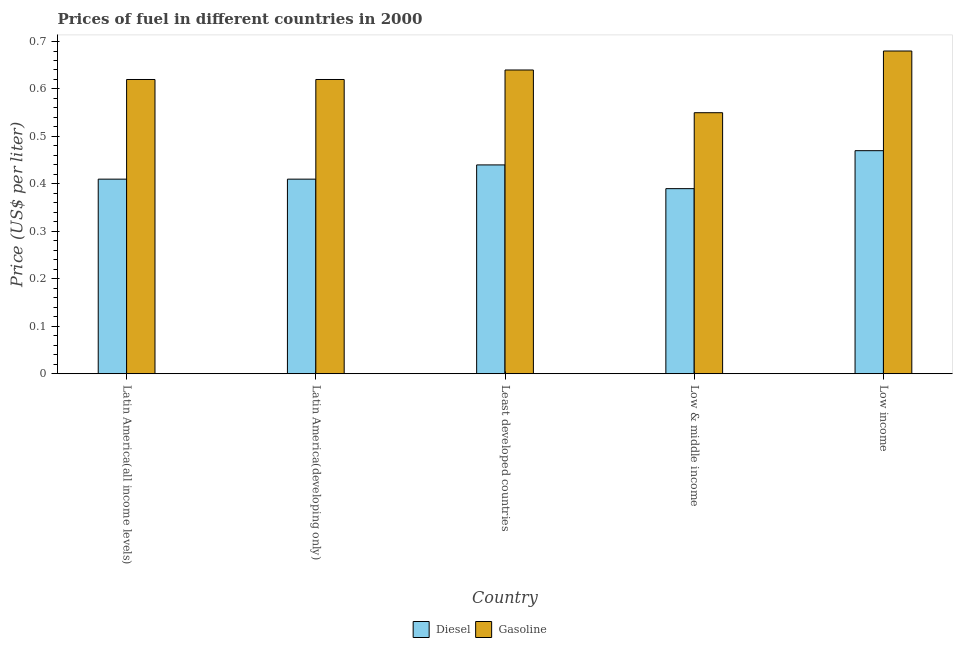How many groups of bars are there?
Your answer should be compact. 5. Are the number of bars per tick equal to the number of legend labels?
Your answer should be compact. Yes. How many bars are there on the 5th tick from the right?
Your answer should be very brief. 2. What is the label of the 3rd group of bars from the left?
Offer a terse response. Least developed countries. What is the gasoline price in Low & middle income?
Make the answer very short. 0.55. Across all countries, what is the maximum diesel price?
Make the answer very short. 0.47. Across all countries, what is the minimum gasoline price?
Give a very brief answer. 0.55. What is the total diesel price in the graph?
Your answer should be compact. 2.12. What is the difference between the gasoline price in Latin America(all income levels) and that in Low & middle income?
Ensure brevity in your answer.  0.07. What is the difference between the diesel price in Latin America(developing only) and the gasoline price in Low & middle income?
Make the answer very short. -0.14. What is the average diesel price per country?
Your answer should be very brief. 0.42. What is the difference between the gasoline price and diesel price in Low income?
Make the answer very short. 0.21. In how many countries, is the diesel price greater than 0.6600000000000001 US$ per litre?
Keep it short and to the point. 0. What is the ratio of the diesel price in Latin America(developing only) to that in Low & middle income?
Give a very brief answer. 1.05. Is the diesel price in Low & middle income less than that in Low income?
Make the answer very short. Yes. What is the difference between the highest and the second highest gasoline price?
Give a very brief answer. 0.04. What is the difference between the highest and the lowest diesel price?
Ensure brevity in your answer.  0.08. What does the 2nd bar from the left in Latin America(all income levels) represents?
Your answer should be compact. Gasoline. What does the 2nd bar from the right in Latin America(developing only) represents?
Offer a terse response. Diesel. Are all the bars in the graph horizontal?
Offer a terse response. No. Does the graph contain any zero values?
Offer a terse response. No. Does the graph contain grids?
Ensure brevity in your answer.  No. How many legend labels are there?
Offer a very short reply. 2. What is the title of the graph?
Give a very brief answer. Prices of fuel in different countries in 2000. Does "Infant" appear as one of the legend labels in the graph?
Your response must be concise. No. What is the label or title of the X-axis?
Offer a terse response. Country. What is the label or title of the Y-axis?
Provide a short and direct response. Price (US$ per liter). What is the Price (US$ per liter) in Diesel in Latin America(all income levels)?
Offer a terse response. 0.41. What is the Price (US$ per liter) of Gasoline in Latin America(all income levels)?
Keep it short and to the point. 0.62. What is the Price (US$ per liter) in Diesel in Latin America(developing only)?
Your answer should be very brief. 0.41. What is the Price (US$ per liter) in Gasoline in Latin America(developing only)?
Make the answer very short. 0.62. What is the Price (US$ per liter) in Diesel in Least developed countries?
Provide a short and direct response. 0.44. What is the Price (US$ per liter) in Gasoline in Least developed countries?
Give a very brief answer. 0.64. What is the Price (US$ per liter) in Diesel in Low & middle income?
Offer a very short reply. 0.39. What is the Price (US$ per liter) of Gasoline in Low & middle income?
Ensure brevity in your answer.  0.55. What is the Price (US$ per liter) in Diesel in Low income?
Keep it short and to the point. 0.47. What is the Price (US$ per liter) of Gasoline in Low income?
Ensure brevity in your answer.  0.68. Across all countries, what is the maximum Price (US$ per liter) in Diesel?
Give a very brief answer. 0.47. Across all countries, what is the maximum Price (US$ per liter) of Gasoline?
Offer a terse response. 0.68. Across all countries, what is the minimum Price (US$ per liter) in Diesel?
Keep it short and to the point. 0.39. Across all countries, what is the minimum Price (US$ per liter) of Gasoline?
Give a very brief answer. 0.55. What is the total Price (US$ per liter) in Diesel in the graph?
Ensure brevity in your answer.  2.12. What is the total Price (US$ per liter) of Gasoline in the graph?
Your response must be concise. 3.11. What is the difference between the Price (US$ per liter) of Diesel in Latin America(all income levels) and that in Latin America(developing only)?
Give a very brief answer. 0. What is the difference between the Price (US$ per liter) of Gasoline in Latin America(all income levels) and that in Latin America(developing only)?
Your response must be concise. 0. What is the difference between the Price (US$ per liter) in Diesel in Latin America(all income levels) and that in Least developed countries?
Provide a succinct answer. -0.03. What is the difference between the Price (US$ per liter) of Gasoline in Latin America(all income levels) and that in Least developed countries?
Ensure brevity in your answer.  -0.02. What is the difference between the Price (US$ per liter) in Diesel in Latin America(all income levels) and that in Low & middle income?
Make the answer very short. 0.02. What is the difference between the Price (US$ per liter) of Gasoline in Latin America(all income levels) and that in Low & middle income?
Your answer should be very brief. 0.07. What is the difference between the Price (US$ per liter) in Diesel in Latin America(all income levels) and that in Low income?
Your response must be concise. -0.06. What is the difference between the Price (US$ per liter) in Gasoline in Latin America(all income levels) and that in Low income?
Offer a terse response. -0.06. What is the difference between the Price (US$ per liter) in Diesel in Latin America(developing only) and that in Least developed countries?
Provide a short and direct response. -0.03. What is the difference between the Price (US$ per liter) of Gasoline in Latin America(developing only) and that in Least developed countries?
Offer a terse response. -0.02. What is the difference between the Price (US$ per liter) in Gasoline in Latin America(developing only) and that in Low & middle income?
Keep it short and to the point. 0.07. What is the difference between the Price (US$ per liter) of Diesel in Latin America(developing only) and that in Low income?
Provide a succinct answer. -0.06. What is the difference between the Price (US$ per liter) in Gasoline in Latin America(developing only) and that in Low income?
Keep it short and to the point. -0.06. What is the difference between the Price (US$ per liter) of Diesel in Least developed countries and that in Low & middle income?
Your answer should be very brief. 0.05. What is the difference between the Price (US$ per liter) in Gasoline in Least developed countries and that in Low & middle income?
Keep it short and to the point. 0.09. What is the difference between the Price (US$ per liter) of Diesel in Least developed countries and that in Low income?
Your answer should be very brief. -0.03. What is the difference between the Price (US$ per liter) in Gasoline in Least developed countries and that in Low income?
Offer a very short reply. -0.04. What is the difference between the Price (US$ per liter) of Diesel in Low & middle income and that in Low income?
Your answer should be compact. -0.08. What is the difference between the Price (US$ per liter) of Gasoline in Low & middle income and that in Low income?
Your answer should be very brief. -0.13. What is the difference between the Price (US$ per liter) of Diesel in Latin America(all income levels) and the Price (US$ per liter) of Gasoline in Latin America(developing only)?
Give a very brief answer. -0.21. What is the difference between the Price (US$ per liter) in Diesel in Latin America(all income levels) and the Price (US$ per liter) in Gasoline in Least developed countries?
Offer a very short reply. -0.23. What is the difference between the Price (US$ per liter) of Diesel in Latin America(all income levels) and the Price (US$ per liter) of Gasoline in Low & middle income?
Provide a succinct answer. -0.14. What is the difference between the Price (US$ per liter) in Diesel in Latin America(all income levels) and the Price (US$ per liter) in Gasoline in Low income?
Offer a very short reply. -0.27. What is the difference between the Price (US$ per liter) of Diesel in Latin America(developing only) and the Price (US$ per liter) of Gasoline in Least developed countries?
Provide a short and direct response. -0.23. What is the difference between the Price (US$ per liter) in Diesel in Latin America(developing only) and the Price (US$ per liter) in Gasoline in Low & middle income?
Provide a succinct answer. -0.14. What is the difference between the Price (US$ per liter) of Diesel in Latin America(developing only) and the Price (US$ per liter) of Gasoline in Low income?
Your response must be concise. -0.27. What is the difference between the Price (US$ per liter) of Diesel in Least developed countries and the Price (US$ per liter) of Gasoline in Low & middle income?
Keep it short and to the point. -0.11. What is the difference between the Price (US$ per liter) of Diesel in Least developed countries and the Price (US$ per liter) of Gasoline in Low income?
Offer a very short reply. -0.24. What is the difference between the Price (US$ per liter) of Diesel in Low & middle income and the Price (US$ per liter) of Gasoline in Low income?
Your response must be concise. -0.29. What is the average Price (US$ per liter) in Diesel per country?
Offer a terse response. 0.42. What is the average Price (US$ per liter) in Gasoline per country?
Offer a very short reply. 0.62. What is the difference between the Price (US$ per liter) in Diesel and Price (US$ per liter) in Gasoline in Latin America(all income levels)?
Your answer should be compact. -0.21. What is the difference between the Price (US$ per liter) of Diesel and Price (US$ per liter) of Gasoline in Latin America(developing only)?
Your answer should be compact. -0.21. What is the difference between the Price (US$ per liter) in Diesel and Price (US$ per liter) in Gasoline in Least developed countries?
Keep it short and to the point. -0.2. What is the difference between the Price (US$ per liter) of Diesel and Price (US$ per liter) of Gasoline in Low & middle income?
Offer a very short reply. -0.16. What is the difference between the Price (US$ per liter) of Diesel and Price (US$ per liter) of Gasoline in Low income?
Keep it short and to the point. -0.21. What is the ratio of the Price (US$ per liter) of Diesel in Latin America(all income levels) to that in Latin America(developing only)?
Provide a succinct answer. 1. What is the ratio of the Price (US$ per liter) in Diesel in Latin America(all income levels) to that in Least developed countries?
Your answer should be very brief. 0.93. What is the ratio of the Price (US$ per liter) in Gasoline in Latin America(all income levels) to that in Least developed countries?
Provide a short and direct response. 0.97. What is the ratio of the Price (US$ per liter) of Diesel in Latin America(all income levels) to that in Low & middle income?
Keep it short and to the point. 1.05. What is the ratio of the Price (US$ per liter) in Gasoline in Latin America(all income levels) to that in Low & middle income?
Offer a very short reply. 1.13. What is the ratio of the Price (US$ per liter) in Diesel in Latin America(all income levels) to that in Low income?
Provide a succinct answer. 0.87. What is the ratio of the Price (US$ per liter) of Gasoline in Latin America(all income levels) to that in Low income?
Your answer should be very brief. 0.91. What is the ratio of the Price (US$ per liter) of Diesel in Latin America(developing only) to that in Least developed countries?
Provide a short and direct response. 0.93. What is the ratio of the Price (US$ per liter) in Gasoline in Latin America(developing only) to that in Least developed countries?
Ensure brevity in your answer.  0.97. What is the ratio of the Price (US$ per liter) in Diesel in Latin America(developing only) to that in Low & middle income?
Give a very brief answer. 1.05. What is the ratio of the Price (US$ per liter) in Gasoline in Latin America(developing only) to that in Low & middle income?
Provide a succinct answer. 1.13. What is the ratio of the Price (US$ per liter) of Diesel in Latin America(developing only) to that in Low income?
Your answer should be compact. 0.87. What is the ratio of the Price (US$ per liter) of Gasoline in Latin America(developing only) to that in Low income?
Provide a succinct answer. 0.91. What is the ratio of the Price (US$ per liter) of Diesel in Least developed countries to that in Low & middle income?
Your response must be concise. 1.13. What is the ratio of the Price (US$ per liter) of Gasoline in Least developed countries to that in Low & middle income?
Keep it short and to the point. 1.16. What is the ratio of the Price (US$ per liter) in Diesel in Least developed countries to that in Low income?
Keep it short and to the point. 0.94. What is the ratio of the Price (US$ per liter) in Gasoline in Least developed countries to that in Low income?
Offer a very short reply. 0.94. What is the ratio of the Price (US$ per liter) in Diesel in Low & middle income to that in Low income?
Your answer should be very brief. 0.83. What is the ratio of the Price (US$ per liter) of Gasoline in Low & middle income to that in Low income?
Give a very brief answer. 0.81. What is the difference between the highest and the lowest Price (US$ per liter) in Gasoline?
Your response must be concise. 0.13. 